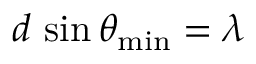<formula> <loc_0><loc_0><loc_500><loc_500>d \, \sin \theta _ { \min } = \lambda</formula> 